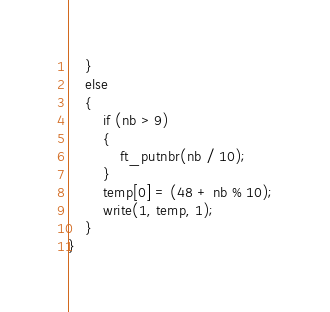Convert code to text. <code><loc_0><loc_0><loc_500><loc_500><_C_>	}
	else
	{
		if (nb > 9)
		{
			ft_putnbr(nb / 10);
		}
		temp[0] = (48 + nb % 10);
		write(1, temp, 1);
	}
}
</code> 